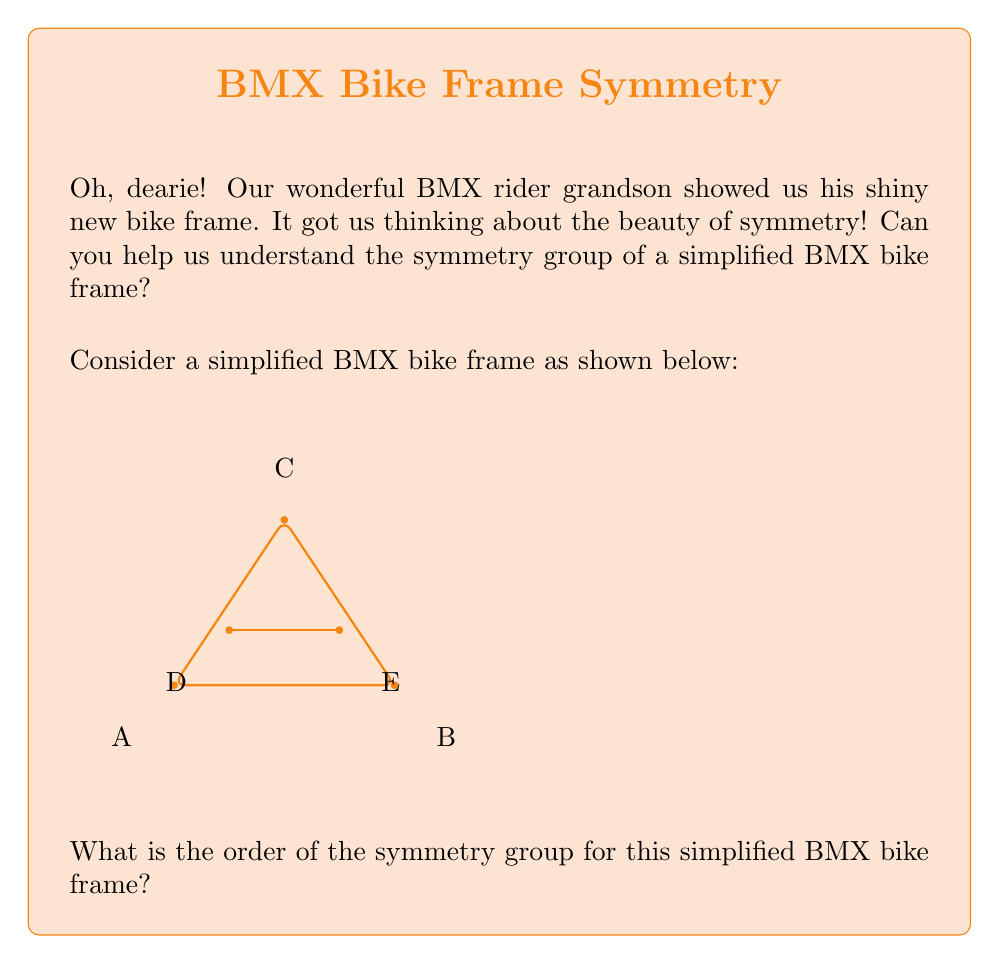Can you solve this math problem? Let's approach this step-by-step, dears!

1) First, we need to identify the symmetries of the frame:

   a) Identity (do nothing): This always exists.
   b) Rotation by 180° around the center: This flips the frame upside-down.
   c) Reflection across the vertical axis: This flips the frame left-to-right.

2) These symmetries form a group under composition. Let's call them:
   
   $e$ : Identity
   $r$ : 180° rotation
   $m$ : Reflection

3) We can verify that these form a group:
   
   - Closure: Combining any two symmetries results in another symmetry.
   - Associativity: This is inherent in geometric transformations.
   - Identity: $e$ is the identity element.
   - Inverse: Each element is its own inverse ($r^2 = e$, $m^2 = e$).

4) This group structure is isomorphic to the cyclic group $C_2$ or the symmetric group $S_2$.

5) To find the order of the group, we simply count the number of distinct elements: $e$, $r$, and $m$.

Therefore, the order of the symmetry group is 3.

Isn't that fascinating, dearies? Just like how our grandson performs three amazing tricks in a row!
Answer: 3 